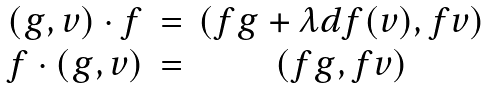Convert formula to latex. <formula><loc_0><loc_0><loc_500><loc_500>\begin{array} { c c c } ( g , v ) \cdot f & = & ( f g + \lambda d f ( v ) , f v ) \\ f \cdot ( g , v ) & = & ( f g , f v ) \end{array}</formula> 